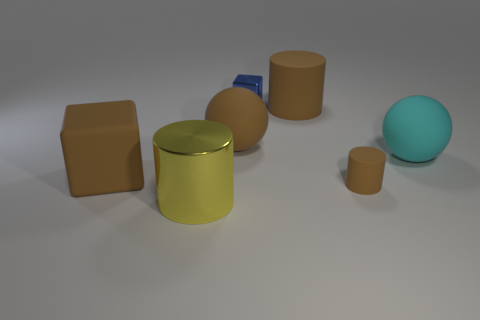What colors are present in the image and how do they affect its mood? The image features a color palette of earth tones such as browns and beige, complemented by a bright yellow and a cyan blue. The yellow object stands out due to its reflective surface and vibrant color, adding a pop of energy to the otherwise subdued scene. The cyan sphere adds a cool contrast to the warm colors and the blue rectangular object introduces a subtle variety. Overall, the colors create a harmonious and visually pleasing atmosphere. 